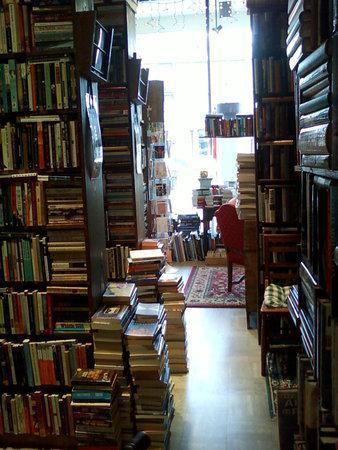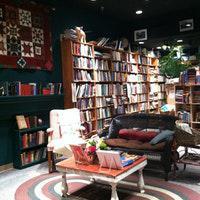The first image is the image on the left, the second image is the image on the right. Evaluate the accuracy of this statement regarding the images: "One image contains more than thirty books and more than two people.". Is it true? Answer yes or no. No. The first image is the image on the left, the second image is the image on the right. Examine the images to the left and right. Is the description "In one of the images, people are actively browsing the books." accurate? Answer yes or no. No. 